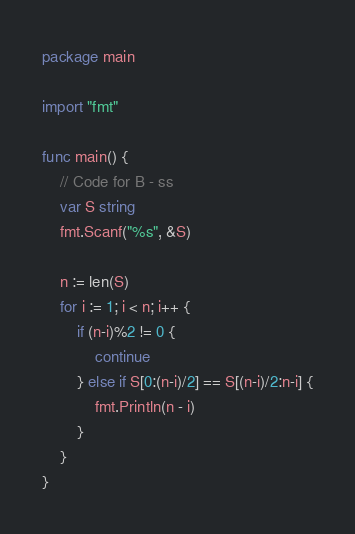<code> <loc_0><loc_0><loc_500><loc_500><_Go_>package main

import "fmt"

func main() {
	// Code for B - ss
	var S string
	fmt.Scanf("%s", &S)

	n := len(S)
	for i := 1; i < n; i++ {
		if (n-i)%2 != 0 {
			continue
		} else if S[0:(n-i)/2] == S[(n-i)/2:n-i] {
			fmt.Println(n - i)
		}
	}
}
</code> 